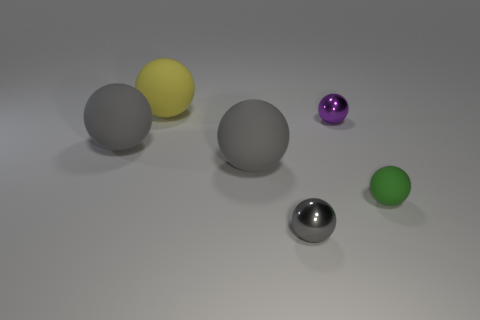What color is the other small metal object that is the same shape as the tiny gray metallic thing?
Give a very brief answer. Purple. How many metallic things are the same color as the small rubber object?
Keep it short and to the point. 0. There is a metal sphere that is behind the gray matte object that is right of the thing that is behind the tiny purple metallic ball; what color is it?
Make the answer very short. Purple. Is the large yellow ball made of the same material as the green ball?
Your answer should be very brief. Yes. Is the green rubber thing the same shape as the yellow thing?
Offer a terse response. Yes. Is the number of rubber spheres on the left side of the large yellow rubber object the same as the number of tiny purple metallic objects that are behind the purple shiny sphere?
Provide a succinct answer. No. There is a tiny object that is the same material as the purple ball; what color is it?
Your response must be concise. Gray. What number of large gray things have the same material as the green object?
Provide a short and direct response. 2. Do the large matte object on the left side of the yellow ball and the tiny rubber object have the same color?
Provide a short and direct response. No. How many other things are the same shape as the yellow rubber thing?
Give a very brief answer. 5. 